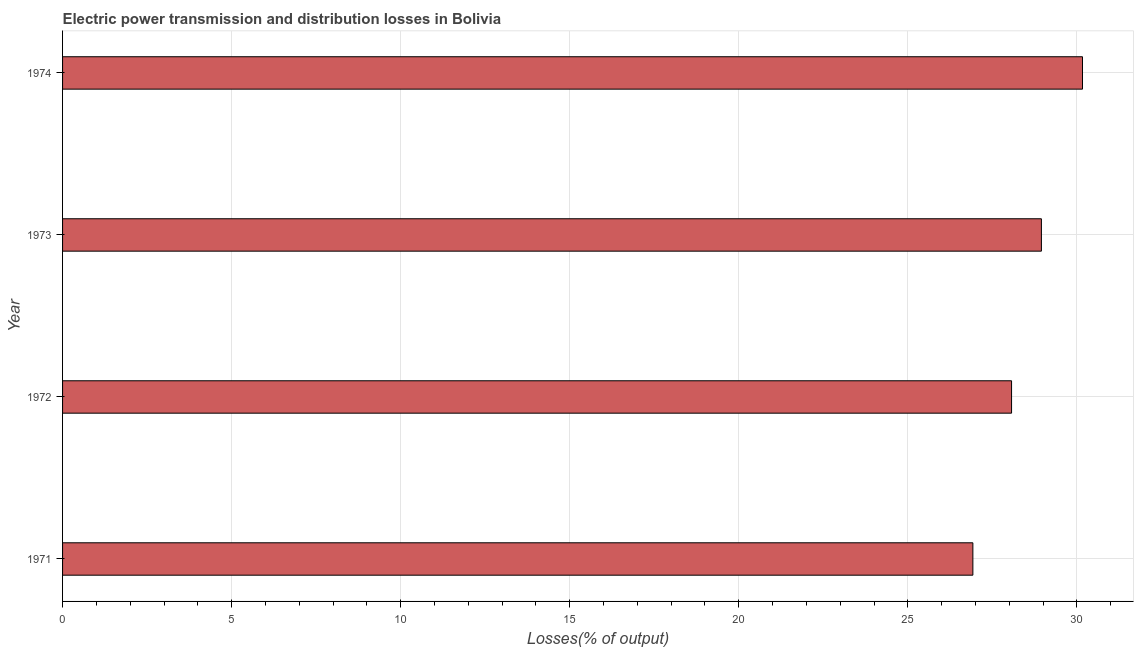What is the title of the graph?
Ensure brevity in your answer.  Electric power transmission and distribution losses in Bolivia. What is the label or title of the X-axis?
Your answer should be very brief. Losses(% of output). What is the label or title of the Y-axis?
Your response must be concise. Year. What is the electric power transmission and distribution losses in 1973?
Your response must be concise. 28.95. Across all years, what is the maximum electric power transmission and distribution losses?
Provide a succinct answer. 30.16. Across all years, what is the minimum electric power transmission and distribution losses?
Ensure brevity in your answer.  26.92. In which year was the electric power transmission and distribution losses maximum?
Provide a succinct answer. 1974. In which year was the electric power transmission and distribution losses minimum?
Provide a short and direct response. 1971. What is the sum of the electric power transmission and distribution losses?
Your answer should be compact. 114.1. What is the difference between the electric power transmission and distribution losses in 1971 and 1972?
Offer a terse response. -1.14. What is the average electric power transmission and distribution losses per year?
Your answer should be very brief. 28.53. What is the median electric power transmission and distribution losses?
Your answer should be very brief. 28.51. Do a majority of the years between 1973 and 1972 (inclusive) have electric power transmission and distribution losses greater than 11 %?
Your answer should be very brief. No. Is the difference between the electric power transmission and distribution losses in 1971 and 1973 greater than the difference between any two years?
Provide a succinct answer. No. What is the difference between the highest and the second highest electric power transmission and distribution losses?
Your response must be concise. 1.22. What is the difference between the highest and the lowest electric power transmission and distribution losses?
Offer a terse response. 3.24. In how many years, is the electric power transmission and distribution losses greater than the average electric power transmission and distribution losses taken over all years?
Ensure brevity in your answer.  2. How many years are there in the graph?
Provide a short and direct response. 4. What is the Losses(% of output) of 1971?
Provide a succinct answer. 26.92. What is the Losses(% of output) of 1972?
Provide a short and direct response. 28.07. What is the Losses(% of output) of 1973?
Your response must be concise. 28.95. What is the Losses(% of output) of 1974?
Your response must be concise. 30.16. What is the difference between the Losses(% of output) in 1971 and 1972?
Provide a succinct answer. -1.14. What is the difference between the Losses(% of output) in 1971 and 1973?
Your answer should be very brief. -2.03. What is the difference between the Losses(% of output) in 1971 and 1974?
Your response must be concise. -3.24. What is the difference between the Losses(% of output) in 1972 and 1973?
Make the answer very short. -0.88. What is the difference between the Losses(% of output) in 1972 and 1974?
Provide a succinct answer. -2.1. What is the difference between the Losses(% of output) in 1973 and 1974?
Give a very brief answer. -1.22. What is the ratio of the Losses(% of output) in 1971 to that in 1973?
Provide a short and direct response. 0.93. What is the ratio of the Losses(% of output) in 1971 to that in 1974?
Provide a succinct answer. 0.89. What is the ratio of the Losses(% of output) in 1972 to that in 1973?
Offer a terse response. 0.97. What is the ratio of the Losses(% of output) in 1972 to that in 1974?
Your response must be concise. 0.93. What is the ratio of the Losses(% of output) in 1973 to that in 1974?
Keep it short and to the point. 0.96. 